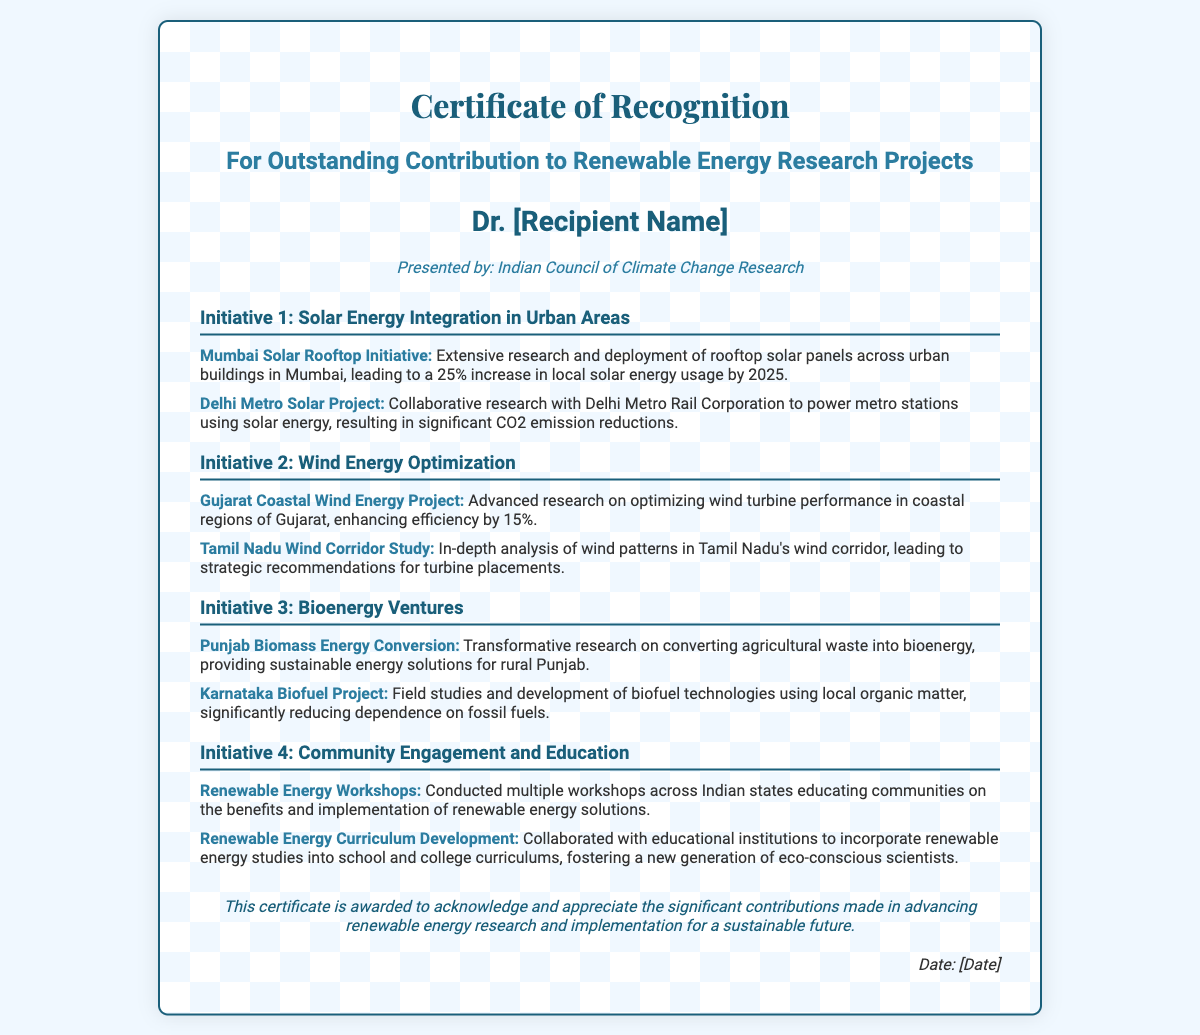What is the title of the certificate? The title "Certificate of Recognition" is prominently displayed at the top of the document.
Answer: Certificate of Recognition Who is the recipient of the certificate? The recipient's name is indicated in the section titled "recipient" in the document.
Answer: Dr. [Recipient Name] Which organization presented the certificate? The presenting organization is specified in the "presented by" line of the document.
Answer: Indian Council of Climate Change Research What is the first initiative listed in the certificate? The first initiative is mentioned in the section headings under the initiatives, specifically in the order they appear.
Answer: Solar Energy Integration in Urban Areas How much efficiency improvement is reported in the Gujarat Coastal Wind Energy Project? The improvement percentage is given in the project description under the wind energy initiative.
Answer: 15% What type of workshops did the certificate mention for community engagement? The workshops aimed at educating communities are specifically referred to in the section detailing community engagement.
Answer: Renewable Energy Workshops What is a key focus of the Punjab Biomass Energy Conversion project? The project focus is outlined in the description following the initiative title.
Answer: Converting agricultural waste into bioenergy How does the certificate describe its purpose? The purpose is conveyed in the footer section, which explains the intent of the awarded recognition.
Answer: Acknowledge and appreciate contributions What is the date placeholder in the certificate labelled as? The date is mentioned distinctly at the end of the certificate.
Answer: Date: [Date] 